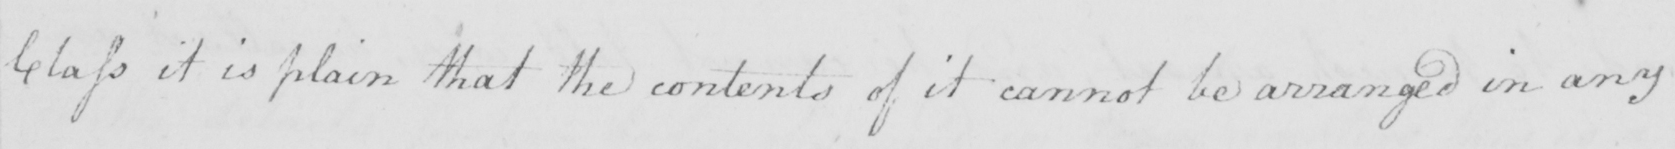Please transcribe the handwritten text in this image. Class it is plain that the contents of it cannot be arranged in any 